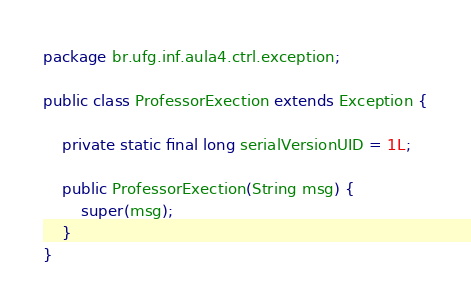Convert code to text. <code><loc_0><loc_0><loc_500><loc_500><_Java_>package br.ufg.inf.aula4.ctrl.exception;

public class ProfessorExection extends Exception {

	private static final long serialVersionUID = 1L;

	public ProfessorExection(String msg) {
		super(msg);
	}
}
</code> 